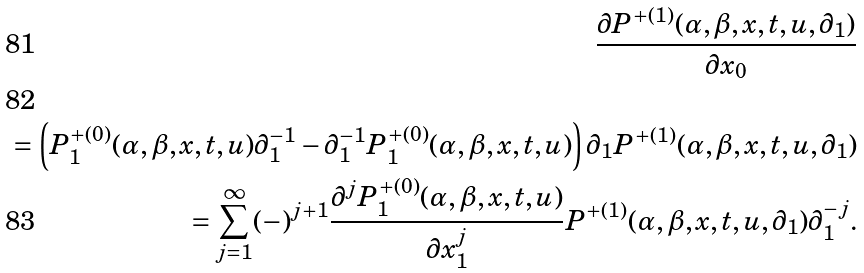<formula> <loc_0><loc_0><loc_500><loc_500>\frac { \partial P ^ { + ( 1 ) } ( \alpha , \beta , x , t , u , \partial _ { 1 } ) } { \partial x _ { 0 } } \\ = \left ( P ^ { + ( 0 ) } _ { 1 } ( \alpha , \beta , x , t , u ) \partial _ { 1 } ^ { - 1 } - \partial _ { 1 } ^ { - 1 } P ^ { + ( 0 ) } _ { 1 } ( \alpha , \beta , x , t , u ) \right ) \partial _ { 1 } P ^ { + ( 1 ) } ( \alpha , \beta , x , t , u , \partial _ { 1 } ) \\ = \sum _ { j = 1 } ^ { \infty } ( - ) ^ { j + 1 } \frac { \partial ^ { j } P ^ { + ( 0 ) } _ { 1 } ( \alpha , \beta , x , t , u ) } { \partial x _ { 1 } ^ { j } } P ^ { + ( 1 ) } ( \alpha , \beta , x , t , u , \partial _ { 1 } ) \partial _ { 1 } ^ { - j } .</formula> 